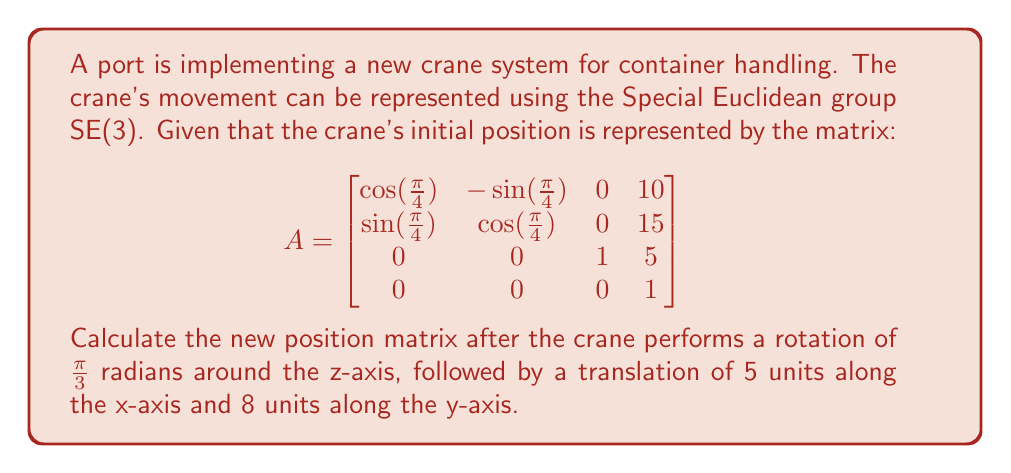Can you answer this question? To solve this problem, we need to use the properties of the Special Euclidean group SE(3) and matrix multiplication. Let's break it down step by step:

1) First, we need to create the transformation matrix for the rotation around the z-axis by $\frac{\pi}{3}$ radians. This rotation matrix is:

   $$R_z(\frac{\pi}{3}) = \begin{bmatrix}
   \cos(\frac{\pi}{3}) & -\sin(\frac{\pi}{3}) & 0 & 0 \\
   \sin(\frac{\pi}{3}) & \cos(\frac{\pi}{3}) & 0 & 0 \\
   0 & 0 & 1 & 0 \\
   0 & 0 & 0 & 1
   \end{bmatrix}$$

2) Next, we need to create the translation matrix for moving 5 units along x-axis and 8 units along y-axis:

   $$T = \begin{bmatrix}
   1 & 0 & 0 & 5 \\
   0 & 1 & 0 & 8 \\
   0 & 0 & 1 & 0 \\
   0 & 0 & 0 & 1
   \end{bmatrix}$$

3) The new position is obtained by multiplying these matrices in the correct order: $T \cdot R_z(\frac{\pi}{3}) \cdot A$

4) Let's perform the multiplication step by step:

   First, $R_z(\frac{\pi}{3}) \cdot A$:
   
   $$\begin{bmatrix}
   \frac{1}{2} & -\frac{\sqrt{3}}{2} & 0 & 0 \\
   \frac{\sqrt{3}}{2} & \frac{1}{2} & 0 & 0 \\
   0 & 0 & 1 & 0 \\
   0 & 0 & 0 & 1
   \end{bmatrix} \cdot 
   \begin{bmatrix}
   \frac{\sqrt{2}}{2} & -\frac{\sqrt{2}}{2} & 0 & 10 \\
   \frac{\sqrt{2}}{2} & \frac{\sqrt{2}}{2} & 0 & 15 \\
   0 & 0 & 1 & 5 \\
   0 & 0 & 0 & 1
   \end{bmatrix}$$

   This results in:

   $$\begin{bmatrix}
   \frac{\sqrt{6}}{4} - \frac{\sqrt{2}}{4} & -\frac{\sqrt{6}}{4} - \frac{\sqrt{2}}{4} & 0 & \frac{5\sqrt{3}}{2} - \frac{5}{2} \\
   \frac{\sqrt{6}}{4} + \frac{\sqrt{2}}{4} & -\frac{\sqrt{6}}{4} + \frac{\sqrt{2}}{4} & 0 & \frac{5\sqrt{3}}{2} + \frac{15}{2} \\
   0 & 0 & 1 & 5 \\
   0 & 0 & 0 & 1
   \end{bmatrix}$$

5) Finally, we multiply this result by T:

   $$\begin{bmatrix}
   1 & 0 & 0 & 5 \\
   0 & 1 & 0 & 8 \\
   0 & 0 & 1 & 0 \\
   0 & 0 & 0 & 1
   \end{bmatrix} \cdot 
   \begin{bmatrix}
   \frac{\sqrt{6}}{4} - \frac{\sqrt{2}}{4} & -\frac{\sqrt{6}}{4} - \frac{\sqrt{2}}{4} & 0 & \frac{5\sqrt{3}}{2} - \frac{5}{2} \\
   \frac{\sqrt{6}}{4} + \frac{\sqrt{2}}{4} & -\frac{\sqrt{6}}{4} + \frac{\sqrt{2}}{4} & 0 & \frac{5\sqrt{3}}{2} + \frac{15}{2} \\
   0 & 0 & 1 & 5 \\
   0 & 0 & 0 & 1
   \end{bmatrix}$$

This gives us the final result.
Answer: The new position matrix after the transformations is:

$$\begin{bmatrix}
\frac{\sqrt{6}}{4} - \frac{\sqrt{2}}{4} & -\frac{\sqrt{6}}{4} - \frac{\sqrt{2}}{4} & 0 & \frac{5\sqrt{3}}{2} + \frac{5}{2} \\
\frac{\sqrt{6}}{4} + \frac{\sqrt{2}}{4} & -\frac{\sqrt{6}}{4} + \frac{\sqrt{2}}{4} & 0 & \frac{5\sqrt{3}}{2} + \frac{31}{2} \\
0 & 0 & 1 & 5 \\
0 & 0 & 0 & 1
\end{bmatrix}$$ 